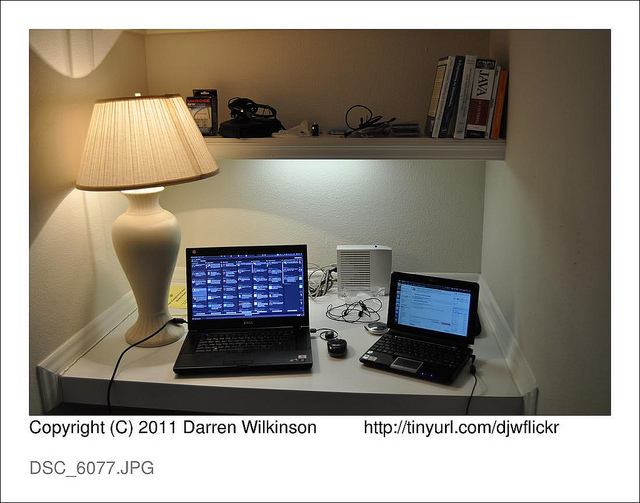Read and extract the text from this image. JAVA C http://tinyurl.com/djwflickr DSC_6077.JPG Wilkinson Darren 2011 Copyright 